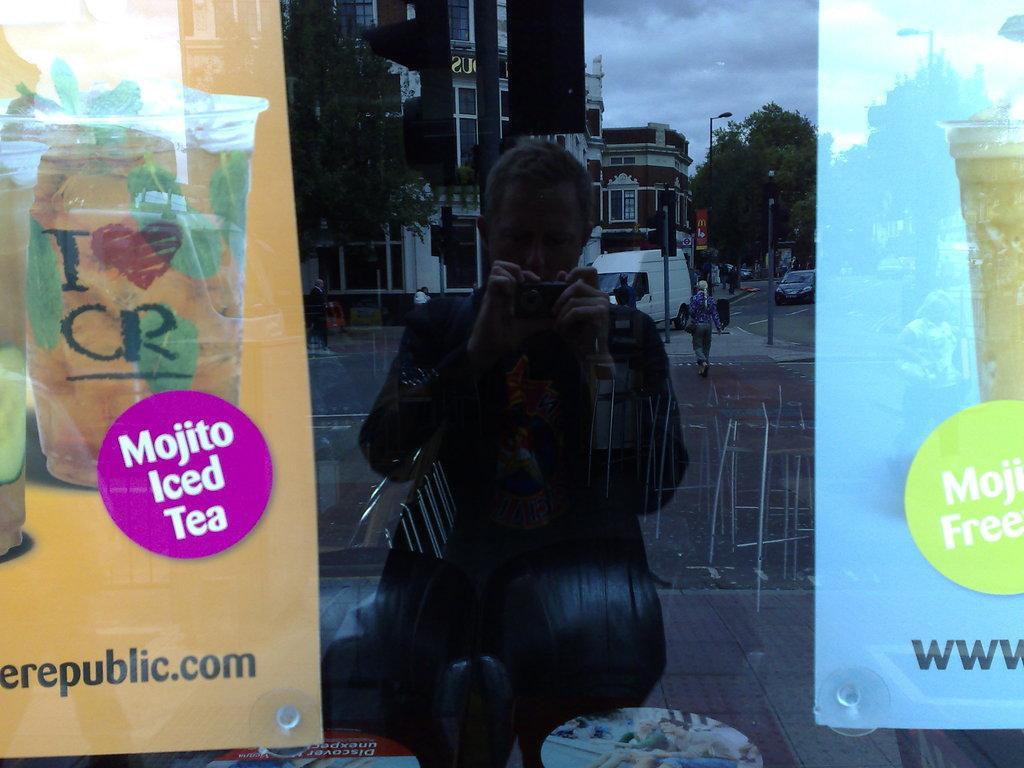In one or two sentences, can you explain what this image depicts? In this image we can see a glass. Behind the glass, we can see the banners. We can see the reflection of the people, poles, vehicles, road, camera, buildings, trees and clouds on the glass. At the bottom of the image, we can see some objects. 